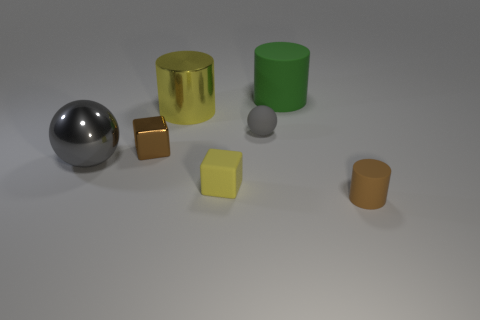Is the size of the rubber cylinder right of the large matte cylinder the same as the sphere to the right of the yellow block?
Ensure brevity in your answer.  Yes. Is the number of small cubes less than the number of large yellow rubber blocks?
Give a very brief answer. No. How many metallic objects are either green cylinders or large gray objects?
Your answer should be compact. 1. There is a metal object that is in front of the metallic cube; are there any small gray objects behind it?
Offer a very short reply. Yes. Is the material of the tiny brown thing in front of the small shiny cube the same as the tiny yellow thing?
Give a very brief answer. Yes. How many other things are the same color as the matte sphere?
Keep it short and to the point. 1. Do the big shiny cylinder and the rubber cube have the same color?
Make the answer very short. Yes. There is a yellow object that is behind the sphere that is in front of the small metallic block; how big is it?
Provide a succinct answer. Large. Is the large cylinder that is behind the big yellow cylinder made of the same material as the tiny cube to the left of the big shiny cylinder?
Provide a short and direct response. No. There is a rubber cylinder in front of the big green cylinder; does it have the same color as the tiny metallic block?
Make the answer very short. Yes. 